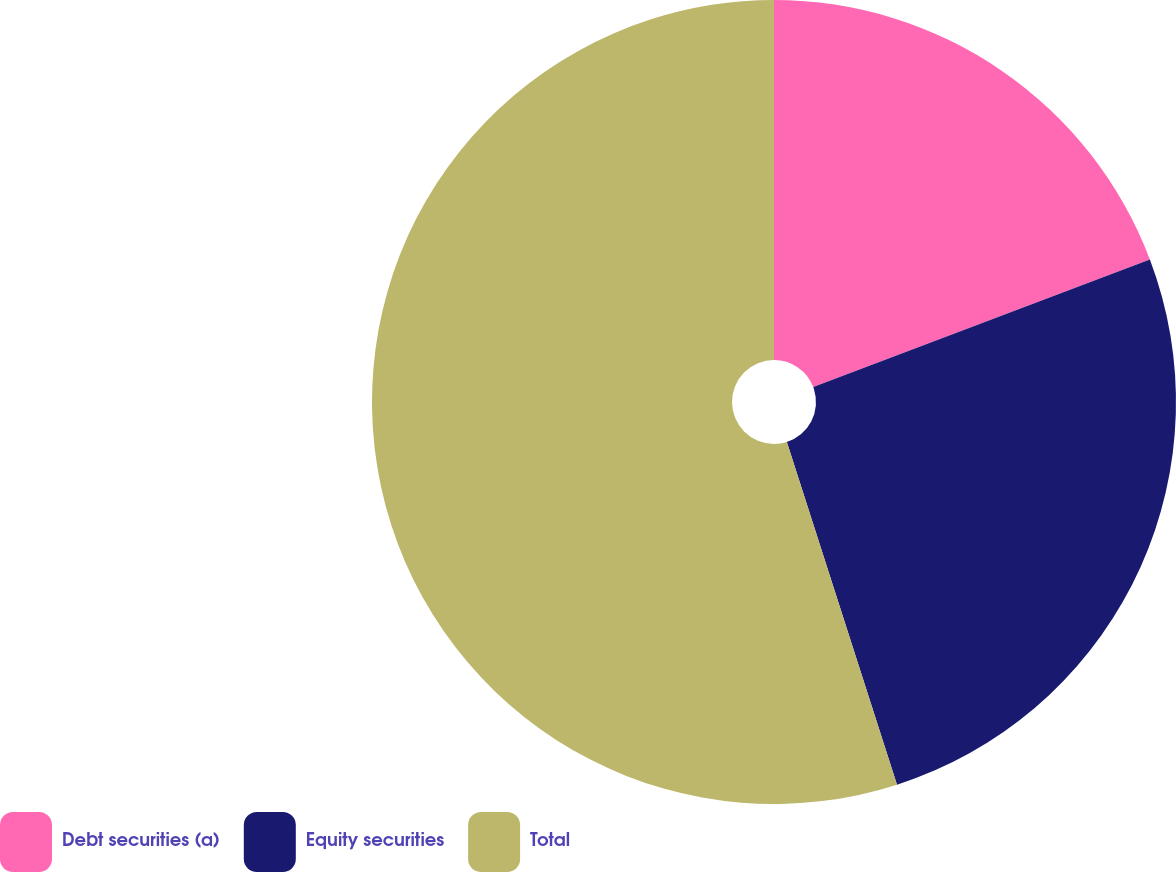Convert chart to OTSL. <chart><loc_0><loc_0><loc_500><loc_500><pie_chart><fcel>Debt securities (a)<fcel>Equity securities<fcel>Total<nl><fcel>19.23%<fcel>25.82%<fcel>54.95%<nl></chart> 